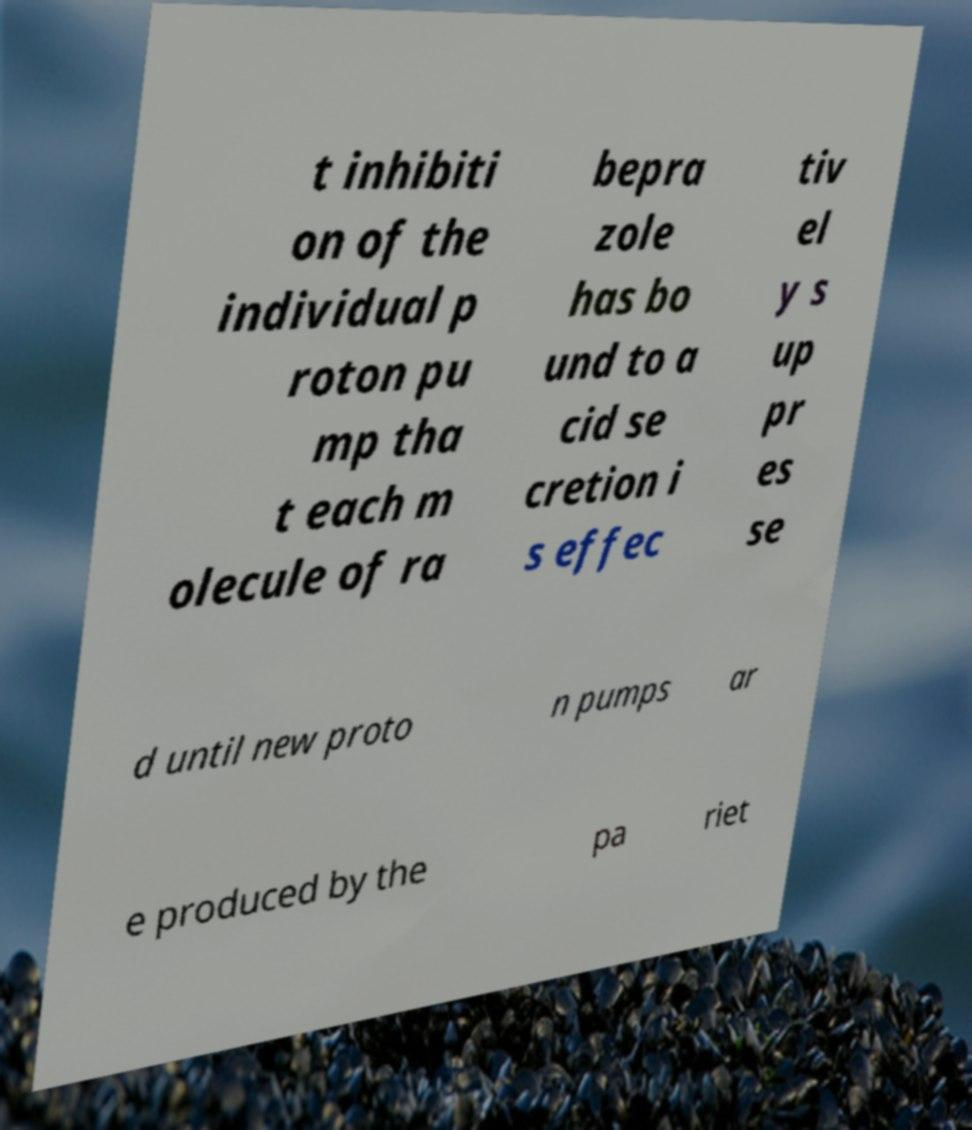Could you assist in decoding the text presented in this image and type it out clearly? t inhibiti on of the individual p roton pu mp tha t each m olecule of ra bepra zole has bo und to a cid se cretion i s effec tiv el y s up pr es se d until new proto n pumps ar e produced by the pa riet 